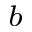<formula> <loc_0><loc_0><loc_500><loc_500>^ { b }</formula> 